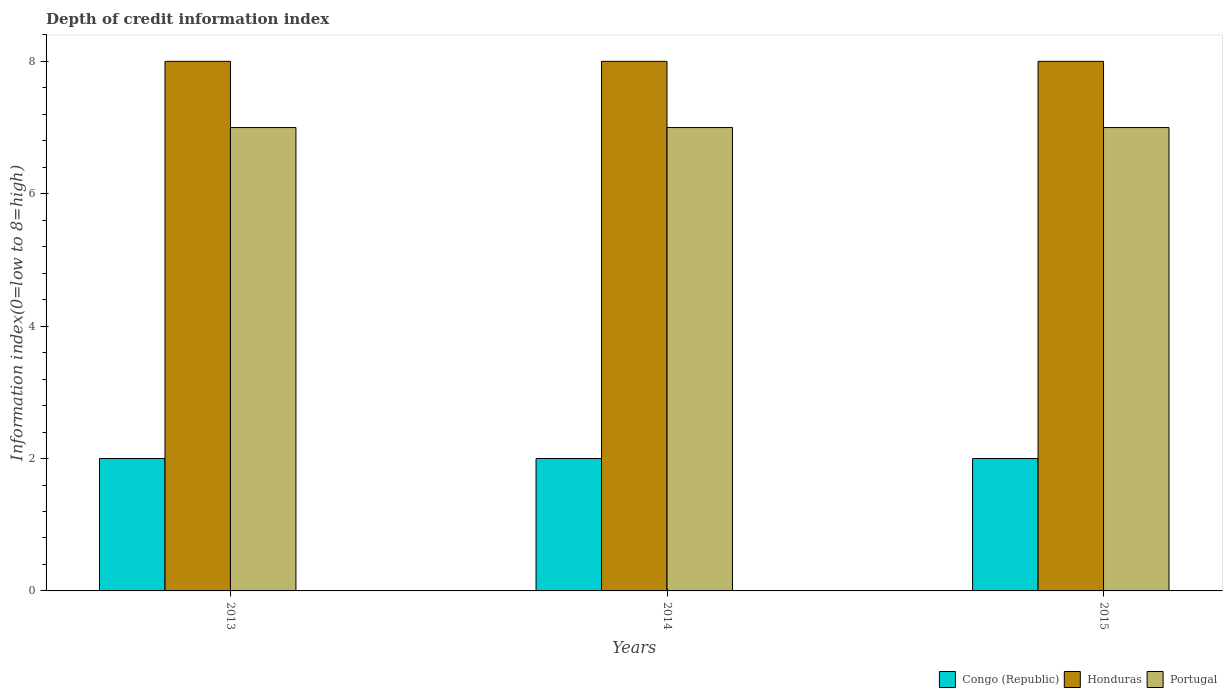How many different coloured bars are there?
Ensure brevity in your answer.  3. Are the number of bars per tick equal to the number of legend labels?
Your response must be concise. Yes. How many bars are there on the 2nd tick from the left?
Your answer should be very brief. 3. How many bars are there on the 1st tick from the right?
Give a very brief answer. 3. What is the label of the 3rd group of bars from the left?
Offer a very short reply. 2015. In how many cases, is the number of bars for a given year not equal to the number of legend labels?
Your response must be concise. 0. What is the information index in Honduras in 2015?
Your answer should be very brief. 8. Across all years, what is the maximum information index in Honduras?
Make the answer very short. 8. Across all years, what is the minimum information index in Congo (Republic)?
Your answer should be very brief. 2. In which year was the information index in Honduras maximum?
Your answer should be very brief. 2013. In which year was the information index in Congo (Republic) minimum?
Provide a short and direct response. 2013. What is the total information index in Portugal in the graph?
Provide a short and direct response. 21. What is the difference between the information index in Congo (Republic) in 2015 and the information index in Portugal in 2013?
Provide a short and direct response. -5. In the year 2013, what is the difference between the information index in Congo (Republic) and information index in Honduras?
Your response must be concise. -6. In how many years, is the information index in Congo (Republic) greater than 5.2?
Provide a succinct answer. 0. Is the information index in Honduras in 2013 less than that in 2015?
Provide a short and direct response. No. Is the difference between the information index in Congo (Republic) in 2013 and 2015 greater than the difference between the information index in Honduras in 2013 and 2015?
Your answer should be very brief. No. In how many years, is the information index in Congo (Republic) greater than the average information index in Congo (Republic) taken over all years?
Ensure brevity in your answer.  0. What does the 1st bar from the left in 2014 represents?
Offer a very short reply. Congo (Republic). Is it the case that in every year, the sum of the information index in Congo (Republic) and information index in Portugal is greater than the information index in Honduras?
Your response must be concise. Yes. Are all the bars in the graph horizontal?
Keep it short and to the point. No. How many years are there in the graph?
Your answer should be compact. 3. What is the difference between two consecutive major ticks on the Y-axis?
Offer a very short reply. 2. Are the values on the major ticks of Y-axis written in scientific E-notation?
Your response must be concise. No. Does the graph contain any zero values?
Make the answer very short. No. Does the graph contain grids?
Your answer should be compact. No. How are the legend labels stacked?
Offer a very short reply. Horizontal. What is the title of the graph?
Offer a very short reply. Depth of credit information index. What is the label or title of the X-axis?
Your response must be concise. Years. What is the label or title of the Y-axis?
Ensure brevity in your answer.  Information index(0=low to 8=high). What is the Information index(0=low to 8=high) of Honduras in 2013?
Offer a terse response. 8. What is the Information index(0=low to 8=high) of Portugal in 2013?
Offer a terse response. 7. What is the Information index(0=low to 8=high) of Congo (Republic) in 2014?
Give a very brief answer. 2. What is the Information index(0=low to 8=high) of Honduras in 2014?
Offer a very short reply. 8. What is the Information index(0=low to 8=high) of Congo (Republic) in 2015?
Ensure brevity in your answer.  2. Across all years, what is the maximum Information index(0=low to 8=high) of Congo (Republic)?
Offer a terse response. 2. Across all years, what is the minimum Information index(0=low to 8=high) of Congo (Republic)?
Ensure brevity in your answer.  2. Across all years, what is the minimum Information index(0=low to 8=high) of Honduras?
Offer a very short reply. 8. What is the difference between the Information index(0=low to 8=high) in Honduras in 2013 and that in 2014?
Provide a short and direct response. 0. What is the difference between the Information index(0=low to 8=high) in Honduras in 2013 and that in 2015?
Offer a terse response. 0. What is the difference between the Information index(0=low to 8=high) in Honduras in 2014 and that in 2015?
Your response must be concise. 0. What is the difference between the Information index(0=low to 8=high) in Portugal in 2014 and that in 2015?
Give a very brief answer. 0. What is the difference between the Information index(0=low to 8=high) in Congo (Republic) in 2014 and the Information index(0=low to 8=high) in Honduras in 2015?
Give a very brief answer. -6. What is the difference between the Information index(0=low to 8=high) of Congo (Republic) in 2014 and the Information index(0=low to 8=high) of Portugal in 2015?
Provide a succinct answer. -5. What is the difference between the Information index(0=low to 8=high) in Honduras in 2014 and the Information index(0=low to 8=high) in Portugal in 2015?
Provide a short and direct response. 1. What is the average Information index(0=low to 8=high) in Congo (Republic) per year?
Your answer should be compact. 2. What is the average Information index(0=low to 8=high) of Portugal per year?
Offer a terse response. 7. In the year 2013, what is the difference between the Information index(0=low to 8=high) in Congo (Republic) and Information index(0=low to 8=high) in Portugal?
Your answer should be very brief. -5. In the year 2014, what is the difference between the Information index(0=low to 8=high) of Honduras and Information index(0=low to 8=high) of Portugal?
Your answer should be very brief. 1. In the year 2015, what is the difference between the Information index(0=low to 8=high) of Congo (Republic) and Information index(0=low to 8=high) of Honduras?
Ensure brevity in your answer.  -6. In the year 2015, what is the difference between the Information index(0=low to 8=high) in Congo (Republic) and Information index(0=low to 8=high) in Portugal?
Offer a terse response. -5. What is the ratio of the Information index(0=low to 8=high) of Congo (Republic) in 2013 to that in 2015?
Ensure brevity in your answer.  1. What is the ratio of the Information index(0=low to 8=high) of Portugal in 2013 to that in 2015?
Offer a very short reply. 1. What is the ratio of the Information index(0=low to 8=high) of Congo (Republic) in 2014 to that in 2015?
Provide a short and direct response. 1. What is the ratio of the Information index(0=low to 8=high) of Honduras in 2014 to that in 2015?
Your answer should be compact. 1. What is the ratio of the Information index(0=low to 8=high) in Portugal in 2014 to that in 2015?
Offer a very short reply. 1. What is the difference between the highest and the second highest Information index(0=low to 8=high) of Congo (Republic)?
Offer a very short reply. 0. What is the difference between the highest and the second highest Information index(0=low to 8=high) of Honduras?
Give a very brief answer. 0. What is the difference between the highest and the lowest Information index(0=low to 8=high) of Honduras?
Provide a short and direct response. 0. What is the difference between the highest and the lowest Information index(0=low to 8=high) of Portugal?
Offer a very short reply. 0. 